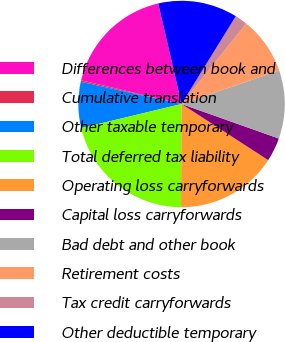<chart> <loc_0><loc_0><loc_500><loc_500><pie_chart><fcel>Differences between book and<fcel>Cumulative translation<fcel>Other taxable temporary<fcel>Total deferred tax liability<fcel>Operating loss carryforwards<fcel>Capital loss carryforwards<fcel>Bad debt and other book<fcel>Retirement costs<fcel>Tax credit carryforwards<fcel>Other deductible temporary<nl><fcel>17.68%<fcel>0.23%<fcel>7.21%<fcel>21.17%<fcel>15.93%<fcel>3.72%<fcel>10.7%<fcel>8.95%<fcel>1.97%<fcel>12.44%<nl></chart> 